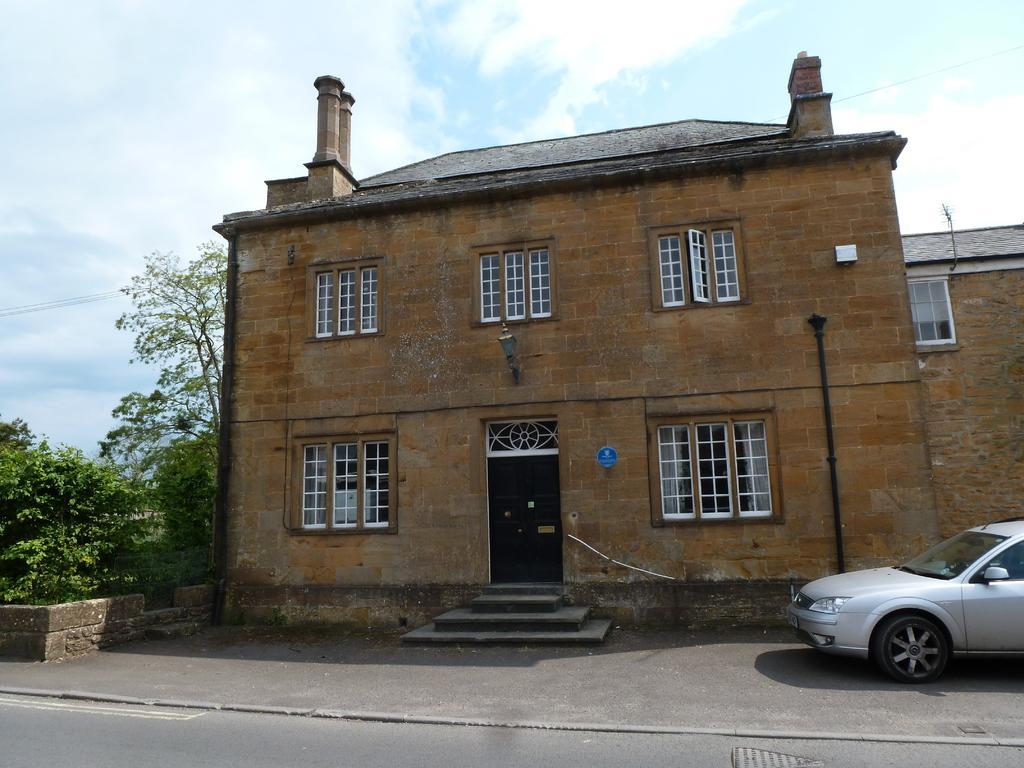In one or two sentences, can you explain what this image depicts? In the center of the image there is a building and light. On the right side of the image we can see car on the road. On the left side of the image we can see trees. In the background there are clouds and sky. 